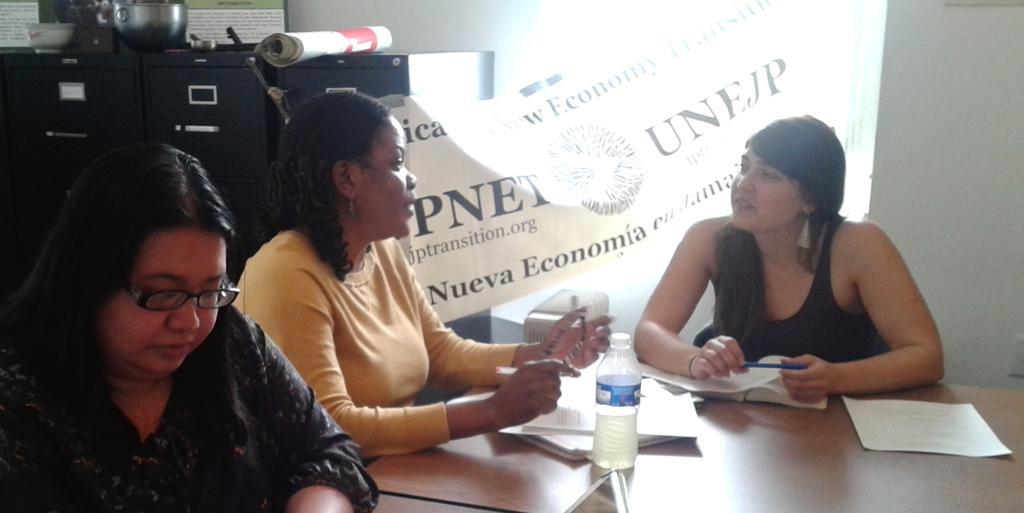Could you give a brief overview of what you see in this image? In this picture there is a woman who is wearing black dress and holding a pen. On the left there is a woman who is wearing spectacle and black dress. Beside her I can see another woman who is sitting near to the table. On the table I can see the papers and water bottle. In the back I can see the banner which is placed near to the window. In the top left corner I can see some banners, bowls, steel objects which are kept on the green color boxes. 